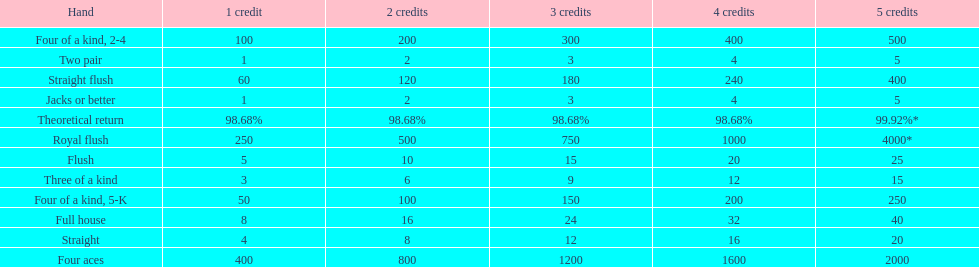What is the difference of payout on 3 credits, between a straight flush and royal flush? 570. 